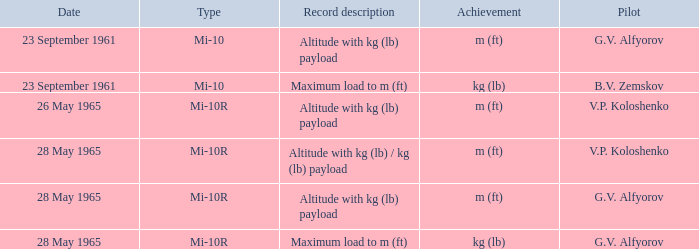Record description of altitude with kg (lb) payload, and a Pilot of g.v. alfyorov had what type? Mi-10, Mi-10R. Parse the full table. {'header': ['Date', 'Type', 'Record description', 'Achievement', 'Pilot'], 'rows': [['23 September 1961', 'Mi-10', 'Altitude with kg (lb) payload', 'm (ft)', 'G.V. Alfyorov'], ['23 September 1961', 'Mi-10', 'Maximum load to m (ft)', 'kg (lb)', 'B.V. Zemskov'], ['26 May 1965', 'Mi-10R', 'Altitude with kg (lb) payload', 'm (ft)', 'V.P. Koloshenko'], ['28 May 1965', 'Mi-10R', 'Altitude with kg (lb) / kg (lb) payload', 'm (ft)', 'V.P. Koloshenko'], ['28 May 1965', 'Mi-10R', 'Altitude with kg (lb) payload', 'm (ft)', 'G.V. Alfyorov'], ['28 May 1965', 'Mi-10R', 'Maximum load to m (ft)', 'kg (lb)', 'G.V. Alfyorov']]} 